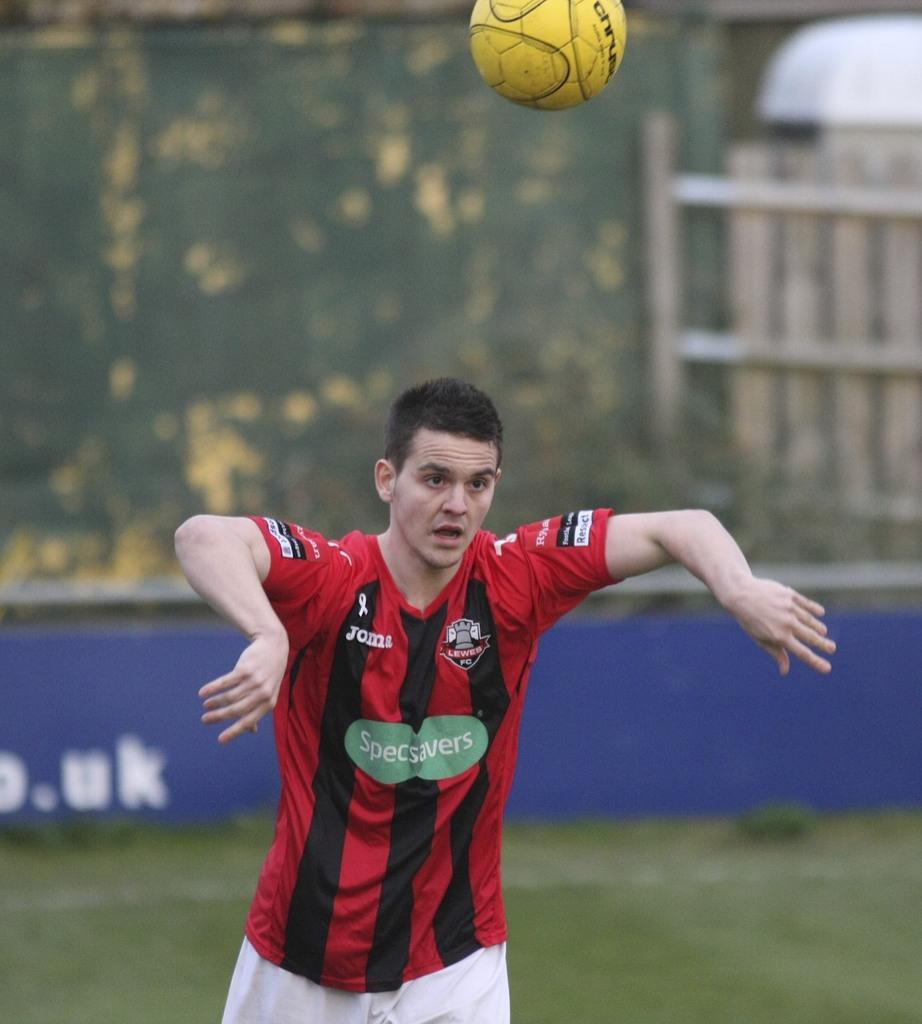<image>
Write a terse but informative summary of the picture. A soccer player with the brand specsavers advertised on his jersey. 